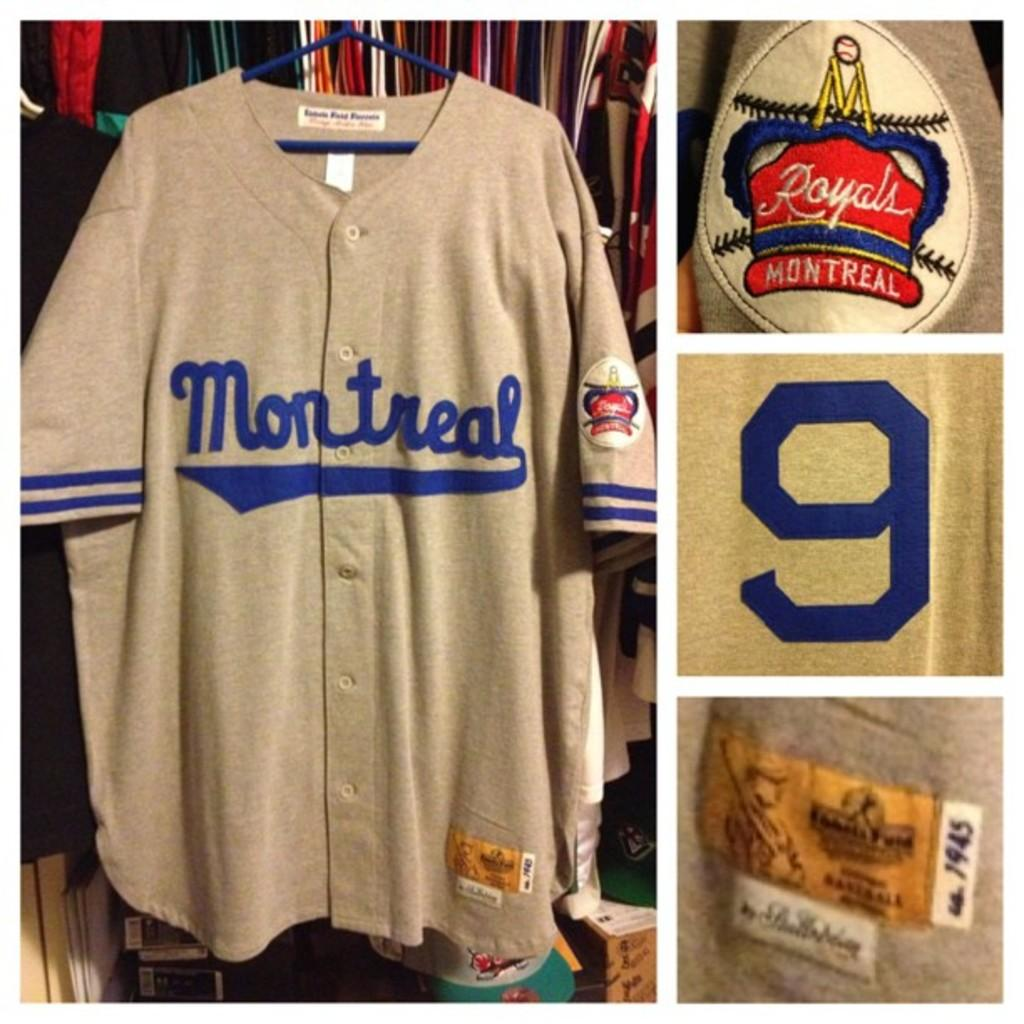<image>
Describe the image concisely. A Montreal jersey hangs on a hanger in front of other clothing. 